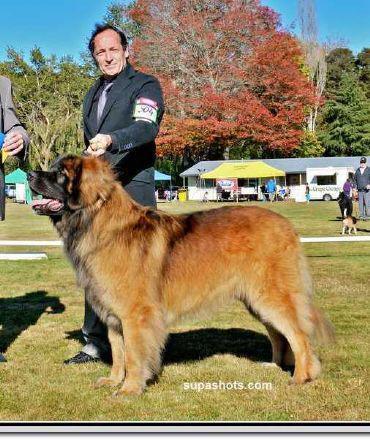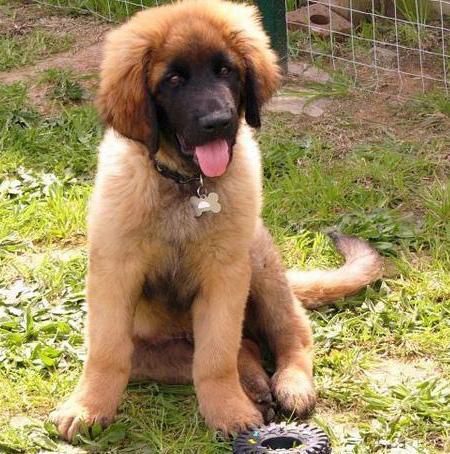The first image is the image on the left, the second image is the image on the right. For the images shown, is this caption "In one image, an adult is standing behind a large dog that has its mouth open." true? Answer yes or no. Yes. The first image is the image on the left, the second image is the image on the right. Examine the images to the left and right. Is the description "there is a child in the image on the left" accurate? Answer yes or no. No. 